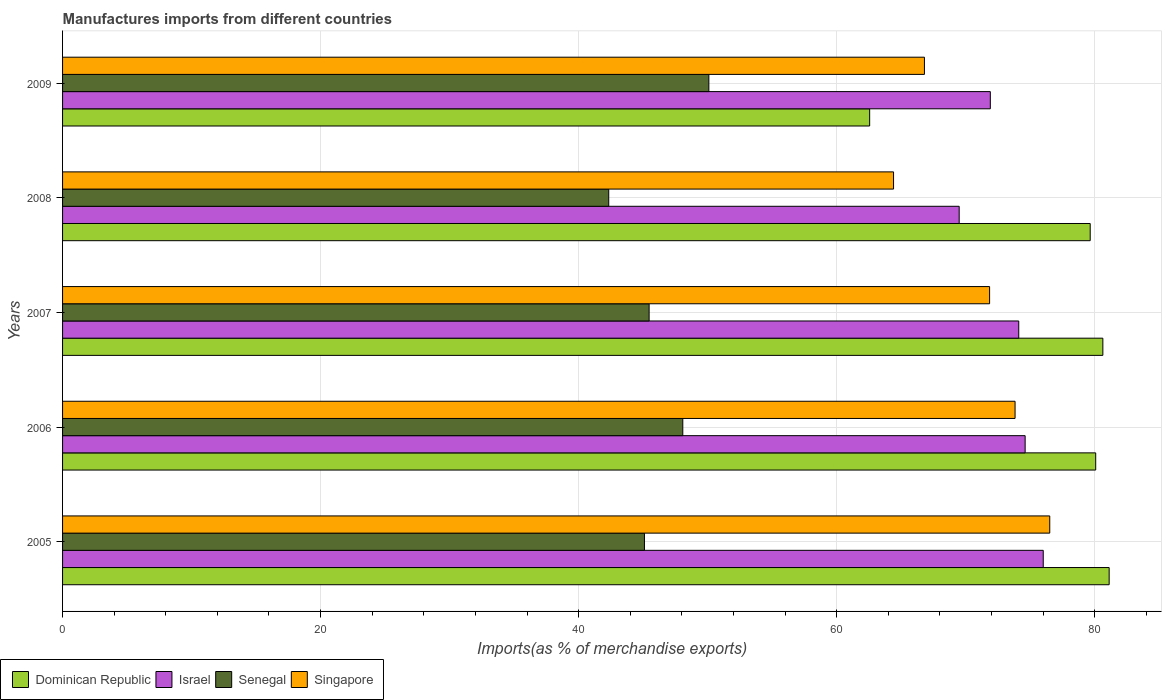How many different coloured bars are there?
Provide a succinct answer. 4. How many groups of bars are there?
Give a very brief answer. 5. Are the number of bars per tick equal to the number of legend labels?
Your answer should be very brief. Yes. How many bars are there on the 2nd tick from the top?
Make the answer very short. 4. How many bars are there on the 3rd tick from the bottom?
Give a very brief answer. 4. What is the label of the 3rd group of bars from the top?
Provide a succinct answer. 2007. In how many cases, is the number of bars for a given year not equal to the number of legend labels?
Provide a short and direct response. 0. What is the percentage of imports to different countries in Dominican Republic in 2006?
Offer a very short reply. 80.08. Across all years, what is the maximum percentage of imports to different countries in Senegal?
Provide a succinct answer. 50.1. Across all years, what is the minimum percentage of imports to different countries in Senegal?
Give a very brief answer. 42.33. In which year was the percentage of imports to different countries in Singapore minimum?
Provide a short and direct response. 2008. What is the total percentage of imports to different countries in Senegal in the graph?
Keep it short and to the point. 231.08. What is the difference between the percentage of imports to different countries in Singapore in 2005 and that in 2007?
Provide a succinct answer. 4.66. What is the difference between the percentage of imports to different countries in Israel in 2006 and the percentage of imports to different countries in Dominican Republic in 2005?
Make the answer very short. -6.51. What is the average percentage of imports to different countries in Israel per year?
Provide a short and direct response. 73.23. In the year 2005, what is the difference between the percentage of imports to different countries in Dominican Republic and percentage of imports to different countries in Singapore?
Offer a very short reply. 4.6. In how many years, is the percentage of imports to different countries in Dominican Republic greater than 12 %?
Provide a succinct answer. 5. What is the ratio of the percentage of imports to different countries in Dominican Republic in 2007 to that in 2009?
Offer a very short reply. 1.29. Is the percentage of imports to different countries in Senegal in 2005 less than that in 2007?
Give a very brief answer. Yes. What is the difference between the highest and the second highest percentage of imports to different countries in Dominican Republic?
Give a very brief answer. 0.49. What is the difference between the highest and the lowest percentage of imports to different countries in Senegal?
Your answer should be very brief. 7.76. Is the sum of the percentage of imports to different countries in Senegal in 2007 and 2008 greater than the maximum percentage of imports to different countries in Singapore across all years?
Your answer should be very brief. Yes. Is it the case that in every year, the sum of the percentage of imports to different countries in Israel and percentage of imports to different countries in Singapore is greater than the sum of percentage of imports to different countries in Senegal and percentage of imports to different countries in Dominican Republic?
Keep it short and to the point. No. What does the 1st bar from the top in 2008 represents?
Provide a succinct answer. Singapore. What does the 2nd bar from the bottom in 2008 represents?
Your response must be concise. Israel. Is it the case that in every year, the sum of the percentage of imports to different countries in Israel and percentage of imports to different countries in Singapore is greater than the percentage of imports to different countries in Dominican Republic?
Make the answer very short. Yes. Are all the bars in the graph horizontal?
Offer a terse response. Yes. Are the values on the major ticks of X-axis written in scientific E-notation?
Provide a short and direct response. No. Where does the legend appear in the graph?
Ensure brevity in your answer.  Bottom left. How many legend labels are there?
Provide a succinct answer. 4. How are the legend labels stacked?
Your response must be concise. Horizontal. What is the title of the graph?
Ensure brevity in your answer.  Manufactures imports from different countries. What is the label or title of the X-axis?
Keep it short and to the point. Imports(as % of merchandise exports). What is the Imports(as % of merchandise exports) in Dominican Republic in 2005?
Keep it short and to the point. 81.12. What is the Imports(as % of merchandise exports) in Israel in 2005?
Provide a succinct answer. 76.02. What is the Imports(as % of merchandise exports) in Senegal in 2005?
Ensure brevity in your answer.  45.1. What is the Imports(as % of merchandise exports) in Singapore in 2005?
Make the answer very short. 76.52. What is the Imports(as % of merchandise exports) in Dominican Republic in 2006?
Your response must be concise. 80.08. What is the Imports(as % of merchandise exports) of Israel in 2006?
Ensure brevity in your answer.  74.61. What is the Imports(as % of merchandise exports) in Senegal in 2006?
Keep it short and to the point. 48.08. What is the Imports(as % of merchandise exports) of Singapore in 2006?
Provide a succinct answer. 73.83. What is the Imports(as % of merchandise exports) in Dominican Republic in 2007?
Your answer should be compact. 80.64. What is the Imports(as % of merchandise exports) of Israel in 2007?
Provide a succinct answer. 74.12. What is the Imports(as % of merchandise exports) of Senegal in 2007?
Offer a very short reply. 45.47. What is the Imports(as % of merchandise exports) in Singapore in 2007?
Offer a terse response. 71.86. What is the Imports(as % of merchandise exports) of Dominican Republic in 2008?
Your answer should be compact. 79.66. What is the Imports(as % of merchandise exports) in Israel in 2008?
Make the answer very short. 69.5. What is the Imports(as % of merchandise exports) of Senegal in 2008?
Give a very brief answer. 42.33. What is the Imports(as % of merchandise exports) in Singapore in 2008?
Give a very brief answer. 64.41. What is the Imports(as % of merchandise exports) of Dominican Republic in 2009?
Offer a very short reply. 62.56. What is the Imports(as % of merchandise exports) in Israel in 2009?
Your answer should be compact. 71.91. What is the Imports(as % of merchandise exports) of Senegal in 2009?
Your answer should be compact. 50.1. What is the Imports(as % of merchandise exports) of Singapore in 2009?
Offer a terse response. 66.81. Across all years, what is the maximum Imports(as % of merchandise exports) of Dominican Republic?
Your answer should be very brief. 81.12. Across all years, what is the maximum Imports(as % of merchandise exports) in Israel?
Offer a terse response. 76.02. Across all years, what is the maximum Imports(as % of merchandise exports) in Senegal?
Ensure brevity in your answer.  50.1. Across all years, what is the maximum Imports(as % of merchandise exports) in Singapore?
Ensure brevity in your answer.  76.52. Across all years, what is the minimum Imports(as % of merchandise exports) in Dominican Republic?
Offer a terse response. 62.56. Across all years, what is the minimum Imports(as % of merchandise exports) of Israel?
Provide a succinct answer. 69.5. Across all years, what is the minimum Imports(as % of merchandise exports) in Senegal?
Provide a short and direct response. 42.33. Across all years, what is the minimum Imports(as % of merchandise exports) in Singapore?
Provide a short and direct response. 64.41. What is the total Imports(as % of merchandise exports) of Dominican Republic in the graph?
Your answer should be very brief. 384.06. What is the total Imports(as % of merchandise exports) of Israel in the graph?
Offer a terse response. 366.16. What is the total Imports(as % of merchandise exports) in Senegal in the graph?
Offer a terse response. 231.08. What is the total Imports(as % of merchandise exports) of Singapore in the graph?
Your answer should be very brief. 353.43. What is the difference between the Imports(as % of merchandise exports) in Dominican Republic in 2005 and that in 2006?
Provide a short and direct response. 1.04. What is the difference between the Imports(as % of merchandise exports) in Israel in 2005 and that in 2006?
Offer a terse response. 1.4. What is the difference between the Imports(as % of merchandise exports) in Senegal in 2005 and that in 2006?
Give a very brief answer. -2.97. What is the difference between the Imports(as % of merchandise exports) of Singapore in 2005 and that in 2006?
Keep it short and to the point. 2.69. What is the difference between the Imports(as % of merchandise exports) in Dominican Republic in 2005 and that in 2007?
Your answer should be compact. 0.49. What is the difference between the Imports(as % of merchandise exports) of Israel in 2005 and that in 2007?
Keep it short and to the point. 1.9. What is the difference between the Imports(as % of merchandise exports) in Senegal in 2005 and that in 2007?
Keep it short and to the point. -0.36. What is the difference between the Imports(as % of merchandise exports) in Singapore in 2005 and that in 2007?
Offer a very short reply. 4.66. What is the difference between the Imports(as % of merchandise exports) of Dominican Republic in 2005 and that in 2008?
Make the answer very short. 1.47. What is the difference between the Imports(as % of merchandise exports) of Israel in 2005 and that in 2008?
Provide a short and direct response. 6.52. What is the difference between the Imports(as % of merchandise exports) of Senegal in 2005 and that in 2008?
Your response must be concise. 2.77. What is the difference between the Imports(as % of merchandise exports) in Singapore in 2005 and that in 2008?
Give a very brief answer. 12.11. What is the difference between the Imports(as % of merchandise exports) of Dominican Republic in 2005 and that in 2009?
Your answer should be very brief. 18.57. What is the difference between the Imports(as % of merchandise exports) in Israel in 2005 and that in 2009?
Your answer should be very brief. 4.1. What is the difference between the Imports(as % of merchandise exports) in Senegal in 2005 and that in 2009?
Provide a succinct answer. -4.99. What is the difference between the Imports(as % of merchandise exports) in Singapore in 2005 and that in 2009?
Provide a short and direct response. 9.71. What is the difference between the Imports(as % of merchandise exports) in Dominican Republic in 2006 and that in 2007?
Provide a succinct answer. -0.55. What is the difference between the Imports(as % of merchandise exports) in Israel in 2006 and that in 2007?
Offer a very short reply. 0.49. What is the difference between the Imports(as % of merchandise exports) of Senegal in 2006 and that in 2007?
Provide a short and direct response. 2.61. What is the difference between the Imports(as % of merchandise exports) of Singapore in 2006 and that in 2007?
Provide a short and direct response. 1.98. What is the difference between the Imports(as % of merchandise exports) of Dominican Republic in 2006 and that in 2008?
Your answer should be very brief. 0.43. What is the difference between the Imports(as % of merchandise exports) in Israel in 2006 and that in 2008?
Provide a succinct answer. 5.11. What is the difference between the Imports(as % of merchandise exports) in Senegal in 2006 and that in 2008?
Ensure brevity in your answer.  5.74. What is the difference between the Imports(as % of merchandise exports) of Singapore in 2006 and that in 2008?
Give a very brief answer. 9.42. What is the difference between the Imports(as % of merchandise exports) in Dominican Republic in 2006 and that in 2009?
Provide a short and direct response. 17.52. What is the difference between the Imports(as % of merchandise exports) in Israel in 2006 and that in 2009?
Provide a short and direct response. 2.7. What is the difference between the Imports(as % of merchandise exports) in Senegal in 2006 and that in 2009?
Ensure brevity in your answer.  -2.02. What is the difference between the Imports(as % of merchandise exports) of Singapore in 2006 and that in 2009?
Provide a succinct answer. 7.03. What is the difference between the Imports(as % of merchandise exports) of Dominican Republic in 2007 and that in 2008?
Offer a very short reply. 0.98. What is the difference between the Imports(as % of merchandise exports) of Israel in 2007 and that in 2008?
Your answer should be very brief. 4.62. What is the difference between the Imports(as % of merchandise exports) of Senegal in 2007 and that in 2008?
Give a very brief answer. 3.13. What is the difference between the Imports(as % of merchandise exports) in Singapore in 2007 and that in 2008?
Give a very brief answer. 7.44. What is the difference between the Imports(as % of merchandise exports) in Dominican Republic in 2007 and that in 2009?
Ensure brevity in your answer.  18.08. What is the difference between the Imports(as % of merchandise exports) of Israel in 2007 and that in 2009?
Your answer should be compact. 2.2. What is the difference between the Imports(as % of merchandise exports) of Senegal in 2007 and that in 2009?
Make the answer very short. -4.63. What is the difference between the Imports(as % of merchandise exports) in Singapore in 2007 and that in 2009?
Your answer should be very brief. 5.05. What is the difference between the Imports(as % of merchandise exports) in Dominican Republic in 2008 and that in 2009?
Give a very brief answer. 17.1. What is the difference between the Imports(as % of merchandise exports) in Israel in 2008 and that in 2009?
Your response must be concise. -2.41. What is the difference between the Imports(as % of merchandise exports) in Senegal in 2008 and that in 2009?
Offer a terse response. -7.76. What is the difference between the Imports(as % of merchandise exports) of Singapore in 2008 and that in 2009?
Your response must be concise. -2.39. What is the difference between the Imports(as % of merchandise exports) of Dominican Republic in 2005 and the Imports(as % of merchandise exports) of Israel in 2006?
Make the answer very short. 6.51. What is the difference between the Imports(as % of merchandise exports) of Dominican Republic in 2005 and the Imports(as % of merchandise exports) of Senegal in 2006?
Offer a terse response. 33.05. What is the difference between the Imports(as % of merchandise exports) of Dominican Republic in 2005 and the Imports(as % of merchandise exports) of Singapore in 2006?
Make the answer very short. 7.29. What is the difference between the Imports(as % of merchandise exports) in Israel in 2005 and the Imports(as % of merchandise exports) in Senegal in 2006?
Ensure brevity in your answer.  27.94. What is the difference between the Imports(as % of merchandise exports) in Israel in 2005 and the Imports(as % of merchandise exports) in Singapore in 2006?
Your answer should be very brief. 2.18. What is the difference between the Imports(as % of merchandise exports) in Senegal in 2005 and the Imports(as % of merchandise exports) in Singapore in 2006?
Offer a very short reply. -28.73. What is the difference between the Imports(as % of merchandise exports) of Dominican Republic in 2005 and the Imports(as % of merchandise exports) of Israel in 2007?
Provide a short and direct response. 7.01. What is the difference between the Imports(as % of merchandise exports) of Dominican Republic in 2005 and the Imports(as % of merchandise exports) of Senegal in 2007?
Offer a very short reply. 35.66. What is the difference between the Imports(as % of merchandise exports) in Dominican Republic in 2005 and the Imports(as % of merchandise exports) in Singapore in 2007?
Provide a short and direct response. 9.27. What is the difference between the Imports(as % of merchandise exports) of Israel in 2005 and the Imports(as % of merchandise exports) of Senegal in 2007?
Your response must be concise. 30.55. What is the difference between the Imports(as % of merchandise exports) of Israel in 2005 and the Imports(as % of merchandise exports) of Singapore in 2007?
Provide a succinct answer. 4.16. What is the difference between the Imports(as % of merchandise exports) of Senegal in 2005 and the Imports(as % of merchandise exports) of Singapore in 2007?
Provide a succinct answer. -26.75. What is the difference between the Imports(as % of merchandise exports) in Dominican Republic in 2005 and the Imports(as % of merchandise exports) in Israel in 2008?
Provide a short and direct response. 11.62. What is the difference between the Imports(as % of merchandise exports) in Dominican Republic in 2005 and the Imports(as % of merchandise exports) in Senegal in 2008?
Your answer should be compact. 38.79. What is the difference between the Imports(as % of merchandise exports) in Dominican Republic in 2005 and the Imports(as % of merchandise exports) in Singapore in 2008?
Your answer should be very brief. 16.71. What is the difference between the Imports(as % of merchandise exports) of Israel in 2005 and the Imports(as % of merchandise exports) of Senegal in 2008?
Ensure brevity in your answer.  33.68. What is the difference between the Imports(as % of merchandise exports) of Israel in 2005 and the Imports(as % of merchandise exports) of Singapore in 2008?
Provide a short and direct response. 11.6. What is the difference between the Imports(as % of merchandise exports) in Senegal in 2005 and the Imports(as % of merchandise exports) in Singapore in 2008?
Keep it short and to the point. -19.31. What is the difference between the Imports(as % of merchandise exports) in Dominican Republic in 2005 and the Imports(as % of merchandise exports) in Israel in 2009?
Give a very brief answer. 9.21. What is the difference between the Imports(as % of merchandise exports) in Dominican Republic in 2005 and the Imports(as % of merchandise exports) in Senegal in 2009?
Ensure brevity in your answer.  31.03. What is the difference between the Imports(as % of merchandise exports) in Dominican Republic in 2005 and the Imports(as % of merchandise exports) in Singapore in 2009?
Your response must be concise. 14.32. What is the difference between the Imports(as % of merchandise exports) in Israel in 2005 and the Imports(as % of merchandise exports) in Senegal in 2009?
Provide a succinct answer. 25.92. What is the difference between the Imports(as % of merchandise exports) of Israel in 2005 and the Imports(as % of merchandise exports) of Singapore in 2009?
Ensure brevity in your answer.  9.21. What is the difference between the Imports(as % of merchandise exports) in Senegal in 2005 and the Imports(as % of merchandise exports) in Singapore in 2009?
Keep it short and to the point. -21.7. What is the difference between the Imports(as % of merchandise exports) in Dominican Republic in 2006 and the Imports(as % of merchandise exports) in Israel in 2007?
Offer a terse response. 5.96. What is the difference between the Imports(as % of merchandise exports) in Dominican Republic in 2006 and the Imports(as % of merchandise exports) in Senegal in 2007?
Your answer should be very brief. 34.62. What is the difference between the Imports(as % of merchandise exports) of Dominican Republic in 2006 and the Imports(as % of merchandise exports) of Singapore in 2007?
Your answer should be very brief. 8.23. What is the difference between the Imports(as % of merchandise exports) of Israel in 2006 and the Imports(as % of merchandise exports) of Senegal in 2007?
Ensure brevity in your answer.  29.15. What is the difference between the Imports(as % of merchandise exports) in Israel in 2006 and the Imports(as % of merchandise exports) in Singapore in 2007?
Offer a very short reply. 2.76. What is the difference between the Imports(as % of merchandise exports) of Senegal in 2006 and the Imports(as % of merchandise exports) of Singapore in 2007?
Provide a short and direct response. -23.78. What is the difference between the Imports(as % of merchandise exports) in Dominican Republic in 2006 and the Imports(as % of merchandise exports) in Israel in 2008?
Keep it short and to the point. 10.58. What is the difference between the Imports(as % of merchandise exports) in Dominican Republic in 2006 and the Imports(as % of merchandise exports) in Senegal in 2008?
Make the answer very short. 37.75. What is the difference between the Imports(as % of merchandise exports) of Dominican Republic in 2006 and the Imports(as % of merchandise exports) of Singapore in 2008?
Ensure brevity in your answer.  15.67. What is the difference between the Imports(as % of merchandise exports) of Israel in 2006 and the Imports(as % of merchandise exports) of Senegal in 2008?
Keep it short and to the point. 32.28. What is the difference between the Imports(as % of merchandise exports) in Israel in 2006 and the Imports(as % of merchandise exports) in Singapore in 2008?
Offer a terse response. 10.2. What is the difference between the Imports(as % of merchandise exports) of Senegal in 2006 and the Imports(as % of merchandise exports) of Singapore in 2008?
Give a very brief answer. -16.34. What is the difference between the Imports(as % of merchandise exports) in Dominican Republic in 2006 and the Imports(as % of merchandise exports) in Israel in 2009?
Make the answer very short. 8.17. What is the difference between the Imports(as % of merchandise exports) of Dominican Republic in 2006 and the Imports(as % of merchandise exports) of Senegal in 2009?
Your answer should be very brief. 29.98. What is the difference between the Imports(as % of merchandise exports) in Dominican Republic in 2006 and the Imports(as % of merchandise exports) in Singapore in 2009?
Keep it short and to the point. 13.28. What is the difference between the Imports(as % of merchandise exports) in Israel in 2006 and the Imports(as % of merchandise exports) in Senegal in 2009?
Offer a terse response. 24.52. What is the difference between the Imports(as % of merchandise exports) in Israel in 2006 and the Imports(as % of merchandise exports) in Singapore in 2009?
Ensure brevity in your answer.  7.81. What is the difference between the Imports(as % of merchandise exports) of Senegal in 2006 and the Imports(as % of merchandise exports) of Singapore in 2009?
Your answer should be very brief. -18.73. What is the difference between the Imports(as % of merchandise exports) in Dominican Republic in 2007 and the Imports(as % of merchandise exports) in Israel in 2008?
Provide a succinct answer. 11.14. What is the difference between the Imports(as % of merchandise exports) of Dominican Republic in 2007 and the Imports(as % of merchandise exports) of Senegal in 2008?
Provide a succinct answer. 38.3. What is the difference between the Imports(as % of merchandise exports) of Dominican Republic in 2007 and the Imports(as % of merchandise exports) of Singapore in 2008?
Provide a short and direct response. 16.22. What is the difference between the Imports(as % of merchandise exports) of Israel in 2007 and the Imports(as % of merchandise exports) of Senegal in 2008?
Offer a terse response. 31.78. What is the difference between the Imports(as % of merchandise exports) of Israel in 2007 and the Imports(as % of merchandise exports) of Singapore in 2008?
Ensure brevity in your answer.  9.71. What is the difference between the Imports(as % of merchandise exports) in Senegal in 2007 and the Imports(as % of merchandise exports) in Singapore in 2008?
Your response must be concise. -18.95. What is the difference between the Imports(as % of merchandise exports) of Dominican Republic in 2007 and the Imports(as % of merchandise exports) of Israel in 2009?
Give a very brief answer. 8.72. What is the difference between the Imports(as % of merchandise exports) in Dominican Republic in 2007 and the Imports(as % of merchandise exports) in Senegal in 2009?
Keep it short and to the point. 30.54. What is the difference between the Imports(as % of merchandise exports) in Dominican Republic in 2007 and the Imports(as % of merchandise exports) in Singapore in 2009?
Provide a short and direct response. 13.83. What is the difference between the Imports(as % of merchandise exports) in Israel in 2007 and the Imports(as % of merchandise exports) in Senegal in 2009?
Provide a short and direct response. 24.02. What is the difference between the Imports(as % of merchandise exports) of Israel in 2007 and the Imports(as % of merchandise exports) of Singapore in 2009?
Provide a succinct answer. 7.31. What is the difference between the Imports(as % of merchandise exports) in Senegal in 2007 and the Imports(as % of merchandise exports) in Singapore in 2009?
Provide a short and direct response. -21.34. What is the difference between the Imports(as % of merchandise exports) in Dominican Republic in 2008 and the Imports(as % of merchandise exports) in Israel in 2009?
Keep it short and to the point. 7.74. What is the difference between the Imports(as % of merchandise exports) in Dominican Republic in 2008 and the Imports(as % of merchandise exports) in Senegal in 2009?
Your response must be concise. 29.56. What is the difference between the Imports(as % of merchandise exports) of Dominican Republic in 2008 and the Imports(as % of merchandise exports) of Singapore in 2009?
Give a very brief answer. 12.85. What is the difference between the Imports(as % of merchandise exports) of Israel in 2008 and the Imports(as % of merchandise exports) of Senegal in 2009?
Your answer should be compact. 19.4. What is the difference between the Imports(as % of merchandise exports) of Israel in 2008 and the Imports(as % of merchandise exports) of Singapore in 2009?
Provide a succinct answer. 2.69. What is the difference between the Imports(as % of merchandise exports) in Senegal in 2008 and the Imports(as % of merchandise exports) in Singapore in 2009?
Offer a very short reply. -24.47. What is the average Imports(as % of merchandise exports) in Dominican Republic per year?
Provide a short and direct response. 76.81. What is the average Imports(as % of merchandise exports) of Israel per year?
Your answer should be very brief. 73.23. What is the average Imports(as % of merchandise exports) in Senegal per year?
Offer a terse response. 46.22. What is the average Imports(as % of merchandise exports) of Singapore per year?
Keep it short and to the point. 70.69. In the year 2005, what is the difference between the Imports(as % of merchandise exports) in Dominican Republic and Imports(as % of merchandise exports) in Israel?
Make the answer very short. 5.11. In the year 2005, what is the difference between the Imports(as % of merchandise exports) in Dominican Republic and Imports(as % of merchandise exports) in Senegal?
Your answer should be very brief. 36.02. In the year 2005, what is the difference between the Imports(as % of merchandise exports) in Dominican Republic and Imports(as % of merchandise exports) in Singapore?
Keep it short and to the point. 4.6. In the year 2005, what is the difference between the Imports(as % of merchandise exports) in Israel and Imports(as % of merchandise exports) in Senegal?
Provide a succinct answer. 30.91. In the year 2005, what is the difference between the Imports(as % of merchandise exports) of Israel and Imports(as % of merchandise exports) of Singapore?
Provide a short and direct response. -0.5. In the year 2005, what is the difference between the Imports(as % of merchandise exports) in Senegal and Imports(as % of merchandise exports) in Singapore?
Provide a short and direct response. -31.42. In the year 2006, what is the difference between the Imports(as % of merchandise exports) in Dominican Republic and Imports(as % of merchandise exports) in Israel?
Offer a terse response. 5.47. In the year 2006, what is the difference between the Imports(as % of merchandise exports) in Dominican Republic and Imports(as % of merchandise exports) in Senegal?
Give a very brief answer. 32.01. In the year 2006, what is the difference between the Imports(as % of merchandise exports) of Dominican Republic and Imports(as % of merchandise exports) of Singapore?
Ensure brevity in your answer.  6.25. In the year 2006, what is the difference between the Imports(as % of merchandise exports) of Israel and Imports(as % of merchandise exports) of Senegal?
Make the answer very short. 26.54. In the year 2006, what is the difference between the Imports(as % of merchandise exports) in Israel and Imports(as % of merchandise exports) in Singapore?
Offer a very short reply. 0.78. In the year 2006, what is the difference between the Imports(as % of merchandise exports) of Senegal and Imports(as % of merchandise exports) of Singapore?
Provide a short and direct response. -25.75. In the year 2007, what is the difference between the Imports(as % of merchandise exports) in Dominican Republic and Imports(as % of merchandise exports) in Israel?
Keep it short and to the point. 6.52. In the year 2007, what is the difference between the Imports(as % of merchandise exports) in Dominican Republic and Imports(as % of merchandise exports) in Senegal?
Your response must be concise. 35.17. In the year 2007, what is the difference between the Imports(as % of merchandise exports) in Dominican Republic and Imports(as % of merchandise exports) in Singapore?
Give a very brief answer. 8.78. In the year 2007, what is the difference between the Imports(as % of merchandise exports) of Israel and Imports(as % of merchandise exports) of Senegal?
Give a very brief answer. 28.65. In the year 2007, what is the difference between the Imports(as % of merchandise exports) of Israel and Imports(as % of merchandise exports) of Singapore?
Offer a very short reply. 2.26. In the year 2007, what is the difference between the Imports(as % of merchandise exports) of Senegal and Imports(as % of merchandise exports) of Singapore?
Offer a terse response. -26.39. In the year 2008, what is the difference between the Imports(as % of merchandise exports) in Dominican Republic and Imports(as % of merchandise exports) in Israel?
Keep it short and to the point. 10.16. In the year 2008, what is the difference between the Imports(as % of merchandise exports) in Dominican Republic and Imports(as % of merchandise exports) in Senegal?
Ensure brevity in your answer.  37.32. In the year 2008, what is the difference between the Imports(as % of merchandise exports) of Dominican Republic and Imports(as % of merchandise exports) of Singapore?
Offer a terse response. 15.24. In the year 2008, what is the difference between the Imports(as % of merchandise exports) of Israel and Imports(as % of merchandise exports) of Senegal?
Provide a short and direct response. 27.17. In the year 2008, what is the difference between the Imports(as % of merchandise exports) in Israel and Imports(as % of merchandise exports) in Singapore?
Provide a short and direct response. 5.09. In the year 2008, what is the difference between the Imports(as % of merchandise exports) of Senegal and Imports(as % of merchandise exports) of Singapore?
Your answer should be compact. -22.08. In the year 2009, what is the difference between the Imports(as % of merchandise exports) in Dominican Republic and Imports(as % of merchandise exports) in Israel?
Ensure brevity in your answer.  -9.35. In the year 2009, what is the difference between the Imports(as % of merchandise exports) in Dominican Republic and Imports(as % of merchandise exports) in Senegal?
Provide a short and direct response. 12.46. In the year 2009, what is the difference between the Imports(as % of merchandise exports) of Dominican Republic and Imports(as % of merchandise exports) of Singapore?
Keep it short and to the point. -4.25. In the year 2009, what is the difference between the Imports(as % of merchandise exports) in Israel and Imports(as % of merchandise exports) in Senegal?
Keep it short and to the point. 21.82. In the year 2009, what is the difference between the Imports(as % of merchandise exports) of Israel and Imports(as % of merchandise exports) of Singapore?
Provide a succinct answer. 5.11. In the year 2009, what is the difference between the Imports(as % of merchandise exports) of Senegal and Imports(as % of merchandise exports) of Singapore?
Give a very brief answer. -16.71. What is the ratio of the Imports(as % of merchandise exports) in Israel in 2005 to that in 2006?
Your answer should be compact. 1.02. What is the ratio of the Imports(as % of merchandise exports) in Senegal in 2005 to that in 2006?
Ensure brevity in your answer.  0.94. What is the ratio of the Imports(as % of merchandise exports) of Singapore in 2005 to that in 2006?
Your answer should be very brief. 1.04. What is the ratio of the Imports(as % of merchandise exports) of Dominican Republic in 2005 to that in 2007?
Your answer should be compact. 1.01. What is the ratio of the Imports(as % of merchandise exports) in Israel in 2005 to that in 2007?
Your answer should be very brief. 1.03. What is the ratio of the Imports(as % of merchandise exports) of Singapore in 2005 to that in 2007?
Ensure brevity in your answer.  1.06. What is the ratio of the Imports(as % of merchandise exports) in Dominican Republic in 2005 to that in 2008?
Make the answer very short. 1.02. What is the ratio of the Imports(as % of merchandise exports) in Israel in 2005 to that in 2008?
Offer a very short reply. 1.09. What is the ratio of the Imports(as % of merchandise exports) in Senegal in 2005 to that in 2008?
Provide a succinct answer. 1.07. What is the ratio of the Imports(as % of merchandise exports) of Singapore in 2005 to that in 2008?
Provide a succinct answer. 1.19. What is the ratio of the Imports(as % of merchandise exports) of Dominican Republic in 2005 to that in 2009?
Offer a very short reply. 1.3. What is the ratio of the Imports(as % of merchandise exports) in Israel in 2005 to that in 2009?
Offer a terse response. 1.06. What is the ratio of the Imports(as % of merchandise exports) of Senegal in 2005 to that in 2009?
Keep it short and to the point. 0.9. What is the ratio of the Imports(as % of merchandise exports) in Singapore in 2005 to that in 2009?
Ensure brevity in your answer.  1.15. What is the ratio of the Imports(as % of merchandise exports) of Dominican Republic in 2006 to that in 2007?
Give a very brief answer. 0.99. What is the ratio of the Imports(as % of merchandise exports) of Israel in 2006 to that in 2007?
Your response must be concise. 1.01. What is the ratio of the Imports(as % of merchandise exports) in Senegal in 2006 to that in 2007?
Offer a very short reply. 1.06. What is the ratio of the Imports(as % of merchandise exports) in Singapore in 2006 to that in 2007?
Offer a terse response. 1.03. What is the ratio of the Imports(as % of merchandise exports) of Dominican Republic in 2006 to that in 2008?
Your answer should be compact. 1.01. What is the ratio of the Imports(as % of merchandise exports) in Israel in 2006 to that in 2008?
Your response must be concise. 1.07. What is the ratio of the Imports(as % of merchandise exports) in Senegal in 2006 to that in 2008?
Offer a terse response. 1.14. What is the ratio of the Imports(as % of merchandise exports) of Singapore in 2006 to that in 2008?
Make the answer very short. 1.15. What is the ratio of the Imports(as % of merchandise exports) in Dominican Republic in 2006 to that in 2009?
Ensure brevity in your answer.  1.28. What is the ratio of the Imports(as % of merchandise exports) of Israel in 2006 to that in 2009?
Provide a short and direct response. 1.04. What is the ratio of the Imports(as % of merchandise exports) of Senegal in 2006 to that in 2009?
Offer a terse response. 0.96. What is the ratio of the Imports(as % of merchandise exports) in Singapore in 2006 to that in 2009?
Make the answer very short. 1.11. What is the ratio of the Imports(as % of merchandise exports) of Dominican Republic in 2007 to that in 2008?
Keep it short and to the point. 1.01. What is the ratio of the Imports(as % of merchandise exports) in Israel in 2007 to that in 2008?
Ensure brevity in your answer.  1.07. What is the ratio of the Imports(as % of merchandise exports) in Senegal in 2007 to that in 2008?
Your answer should be very brief. 1.07. What is the ratio of the Imports(as % of merchandise exports) of Singapore in 2007 to that in 2008?
Your answer should be very brief. 1.12. What is the ratio of the Imports(as % of merchandise exports) in Dominican Republic in 2007 to that in 2009?
Provide a succinct answer. 1.29. What is the ratio of the Imports(as % of merchandise exports) in Israel in 2007 to that in 2009?
Your answer should be compact. 1.03. What is the ratio of the Imports(as % of merchandise exports) in Senegal in 2007 to that in 2009?
Ensure brevity in your answer.  0.91. What is the ratio of the Imports(as % of merchandise exports) of Singapore in 2007 to that in 2009?
Provide a short and direct response. 1.08. What is the ratio of the Imports(as % of merchandise exports) of Dominican Republic in 2008 to that in 2009?
Your response must be concise. 1.27. What is the ratio of the Imports(as % of merchandise exports) of Israel in 2008 to that in 2009?
Make the answer very short. 0.97. What is the ratio of the Imports(as % of merchandise exports) in Senegal in 2008 to that in 2009?
Give a very brief answer. 0.85. What is the ratio of the Imports(as % of merchandise exports) in Singapore in 2008 to that in 2009?
Give a very brief answer. 0.96. What is the difference between the highest and the second highest Imports(as % of merchandise exports) of Dominican Republic?
Offer a terse response. 0.49. What is the difference between the highest and the second highest Imports(as % of merchandise exports) of Israel?
Your response must be concise. 1.4. What is the difference between the highest and the second highest Imports(as % of merchandise exports) in Senegal?
Provide a short and direct response. 2.02. What is the difference between the highest and the second highest Imports(as % of merchandise exports) in Singapore?
Provide a succinct answer. 2.69. What is the difference between the highest and the lowest Imports(as % of merchandise exports) of Dominican Republic?
Provide a short and direct response. 18.57. What is the difference between the highest and the lowest Imports(as % of merchandise exports) of Israel?
Give a very brief answer. 6.52. What is the difference between the highest and the lowest Imports(as % of merchandise exports) in Senegal?
Give a very brief answer. 7.76. What is the difference between the highest and the lowest Imports(as % of merchandise exports) in Singapore?
Provide a short and direct response. 12.11. 